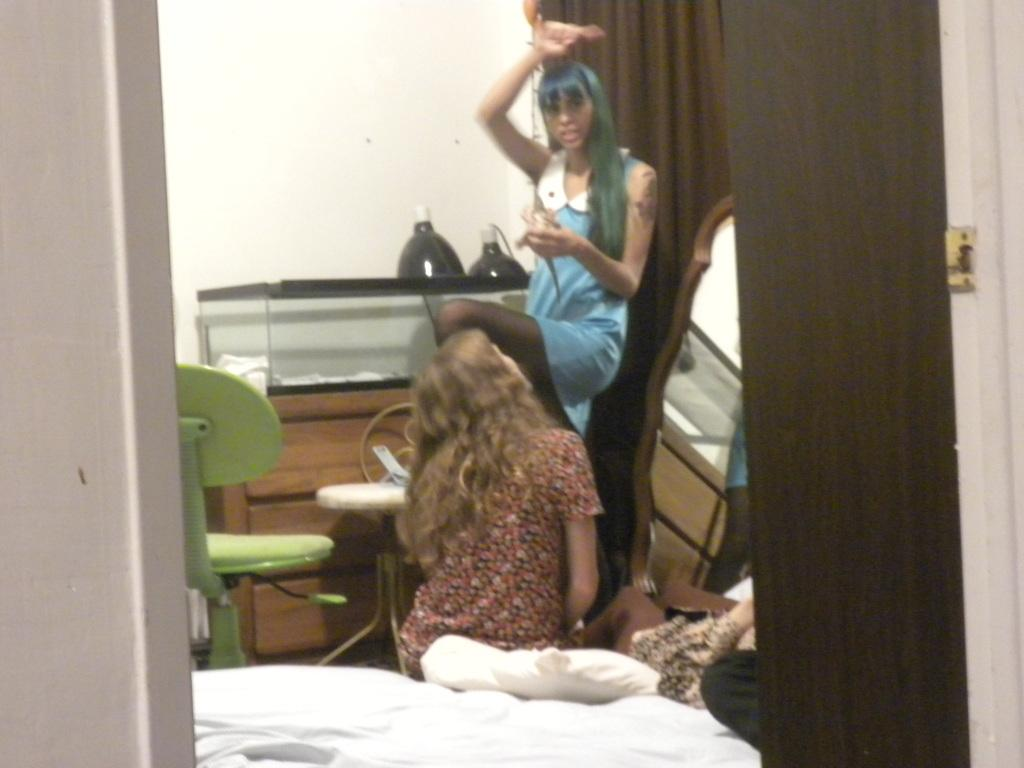How many people are present in the image? There are two people in the image, one standing and one sitting on the bed. What type of furniture is in the image? There is a chair in the image. What can be used for personal grooming or reflection in the image? There is a mirror in the image. What type of objects are present in the image? There are objects in the image, but their specific nature is not mentioned in the facts. What type of window treatment is present in the image? There is a curtain in the image. What can be used for comfort or support while sitting or sleeping in the image? There is a pillow in the image. What type of architectural feature is present in the image? There is a wall in the image. What type of nest can be seen in the image? There is no nest present in the image. What type of brass object is visible in the image? There is no brass object mentioned in the facts provided. 